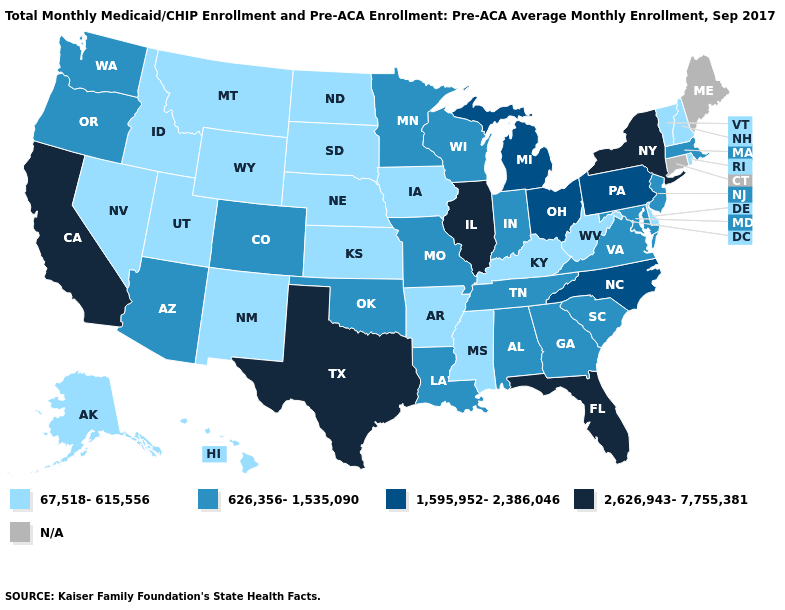Name the states that have a value in the range 626,356-1,535,090?
Short answer required. Alabama, Arizona, Colorado, Georgia, Indiana, Louisiana, Maryland, Massachusetts, Minnesota, Missouri, New Jersey, Oklahoma, Oregon, South Carolina, Tennessee, Virginia, Washington, Wisconsin. What is the value of Louisiana?
Answer briefly. 626,356-1,535,090. What is the lowest value in the Northeast?
Short answer required. 67,518-615,556. Name the states that have a value in the range 626,356-1,535,090?
Keep it brief. Alabama, Arizona, Colorado, Georgia, Indiana, Louisiana, Maryland, Massachusetts, Minnesota, Missouri, New Jersey, Oklahoma, Oregon, South Carolina, Tennessee, Virginia, Washington, Wisconsin. Does Mississippi have the lowest value in the South?
Write a very short answer. Yes. What is the value of Delaware?
Answer briefly. 67,518-615,556. How many symbols are there in the legend?
Be succinct. 5. What is the value of Wisconsin?
Short answer required. 626,356-1,535,090. Does the map have missing data?
Quick response, please. Yes. What is the value of Kentucky?
Be succinct. 67,518-615,556. What is the value of South Carolina?
Keep it brief. 626,356-1,535,090. Name the states that have a value in the range N/A?
Write a very short answer. Connecticut, Maine. What is the lowest value in states that border Montana?
Quick response, please. 67,518-615,556. What is the highest value in the MidWest ?
Concise answer only. 2,626,943-7,755,381. 